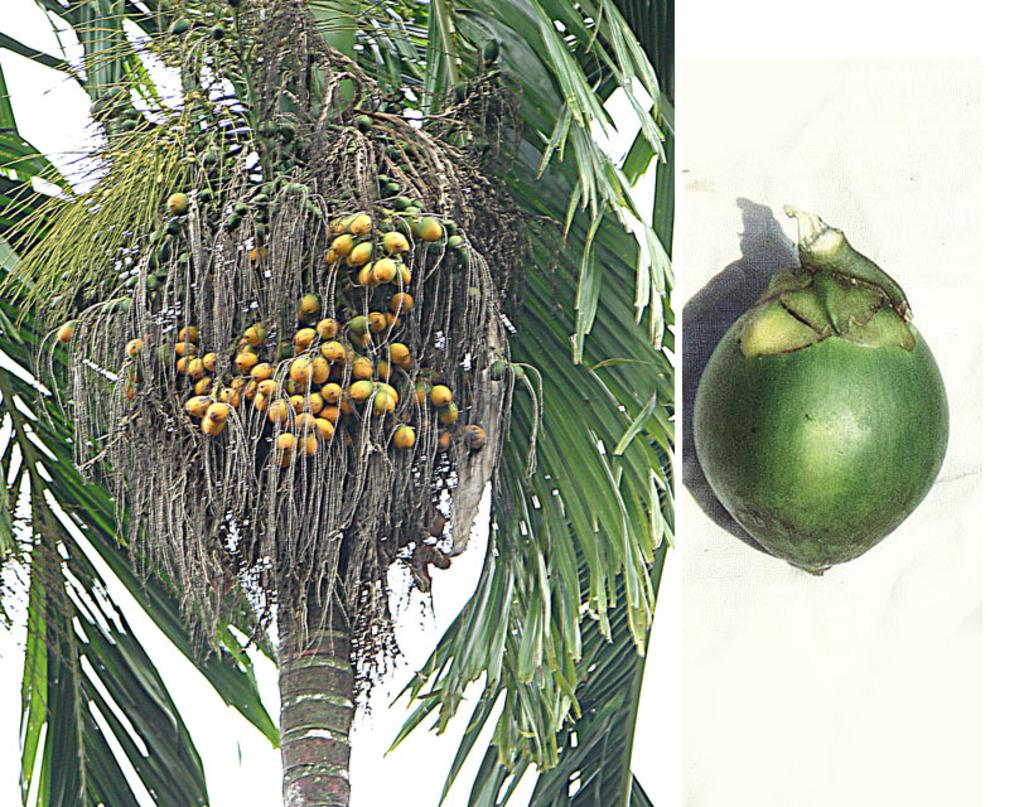What type of artwork is the image? The image is a collage. What can be seen on the tree in the image? There are fruits on a tree in the image. What part of the natural environment is visible in the image? The sky is visible in the image. What type of mailbox can be seen in the image? There is no mailbox present in the image. Who created the collage in the image? The creator of the collage is not mentioned in the image, so it cannot be determined from the image. What type of window treatment is visible in the image? There is no window treatment visible in the image, as it does not depict any indoor scenes. 